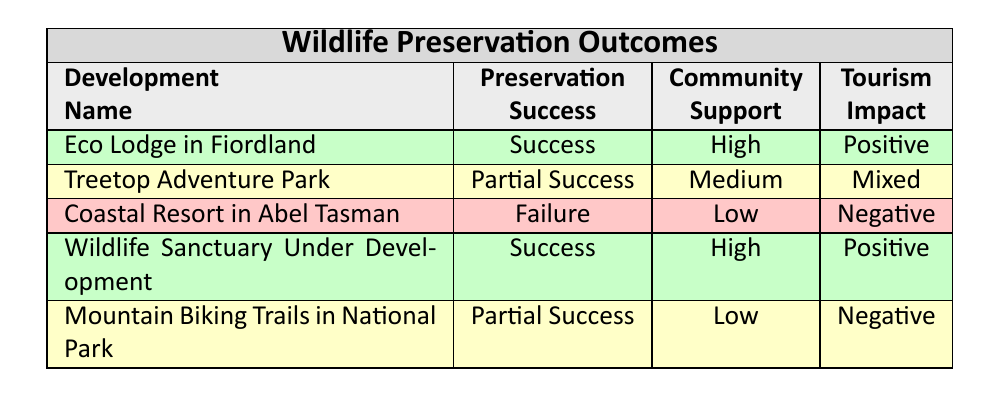What are the tourism impacts of the Coastal Resort in Abel Tasman? The table shows that the tourism impact of the Coastal Resort in Abel Tasman is "Negative." This is directly referenced in the table's "Tourism Impact" column for this specific development.
Answer: Negative How many developments reported a "Success" in wildlife preservation? The table lists two developments with a "Success" label in the "Preservation" column: Eco Lodge in Fiordland and Wildlife Sanctuary Under Development. Therefore, there are 2 developments that reported a success.
Answer: 2 Is community support high for the Treetop Adventure Park? The table indicates that the community support for the Treetop Adventure Park is "Medium," which means it is not categorized as high. Therefore, the statement is false.
Answer: No What is the average community support level among all developments? The community support levels listed are High, Medium, Low, High, Low. If we assign values (High = 3, Medium = 2, Low = 1), we have: (3 + 2 + 1 + 3 + 1) / 5 = 2. The average community support level is therefore Medium.
Answer: Medium Which development has the most positive tourism impact? By examining the "Tourism Impact" column, both Eco Lodge in Fiordland and Wildlife Sanctuary Under Development are noted as having a "Positive" impact. Since they are both positive, they are tied for the best impact.
Answer: Eco Lodge in Fiordland and Wildlife Sanctuary Under Development What percentage of the developments had either partial or no success in wildlife preservation? There are a total of 5 developments. "Partial Success" is indicated for Treetop Adventure Park and Mountain Biking Trails in National Park and "Failure" for the Coastal Resort. That's 3 out of 5 developments that had either partial or no success. Hence, the percentage is (3/5) * 100 = 60%.
Answer: 60% Did all developments with high community support also report a positive tourism impact? The Eco Lodge in Fiordland and Wildlife Sanctuary Under Development both show "High" community support and they also report "Positive" tourism impact. Therefore, the statement holds true for those two cases.
Answer: Yes Which species were affected by the development with the highest tourism impact? The development with the highest tourism impact is Eco Lodge in Fiordland with a "Positive" impact. The species affected, according to the table, are Kiwi and Kea.
Answer: Kiwi, Kea What is the relationship between community support and wildlife preservation success in the table? Analyzing the table, high community support appears in developments with both successful outcomes (Eco Lodge, Wildlife Sanctuary) and negative impacts (Coastal Resort). Similarly, low community support corresponds with partial success and negative impact (Mountain Biking Trails). Thus, high community support does not guarantee a successful wildlife preservation outcome, indicating a complex relationship.
Answer: Complex relationship without a clear correlation 